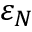<formula> <loc_0><loc_0><loc_500><loc_500>\varepsilon _ { N }</formula> 